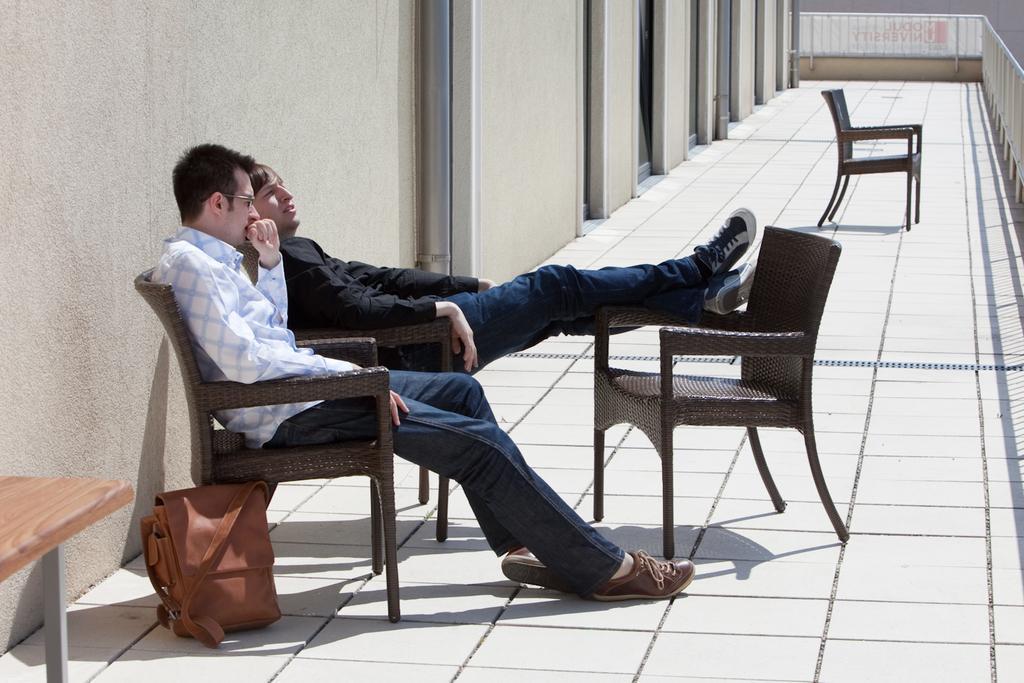In one or two sentences, can you explain what this image depicts? In the left middle, two persons are sitting on the chair and a bag is kept on the ground. And a table half visible. The background walls are white in color and fence of balcony is visible. On both sides doors are visible. This image is taken in a balcony during day time. 